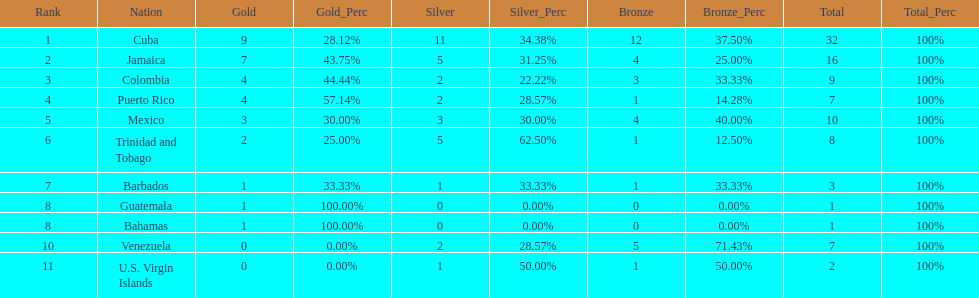Who had more silvers? colmbia or the bahamas Colombia. 